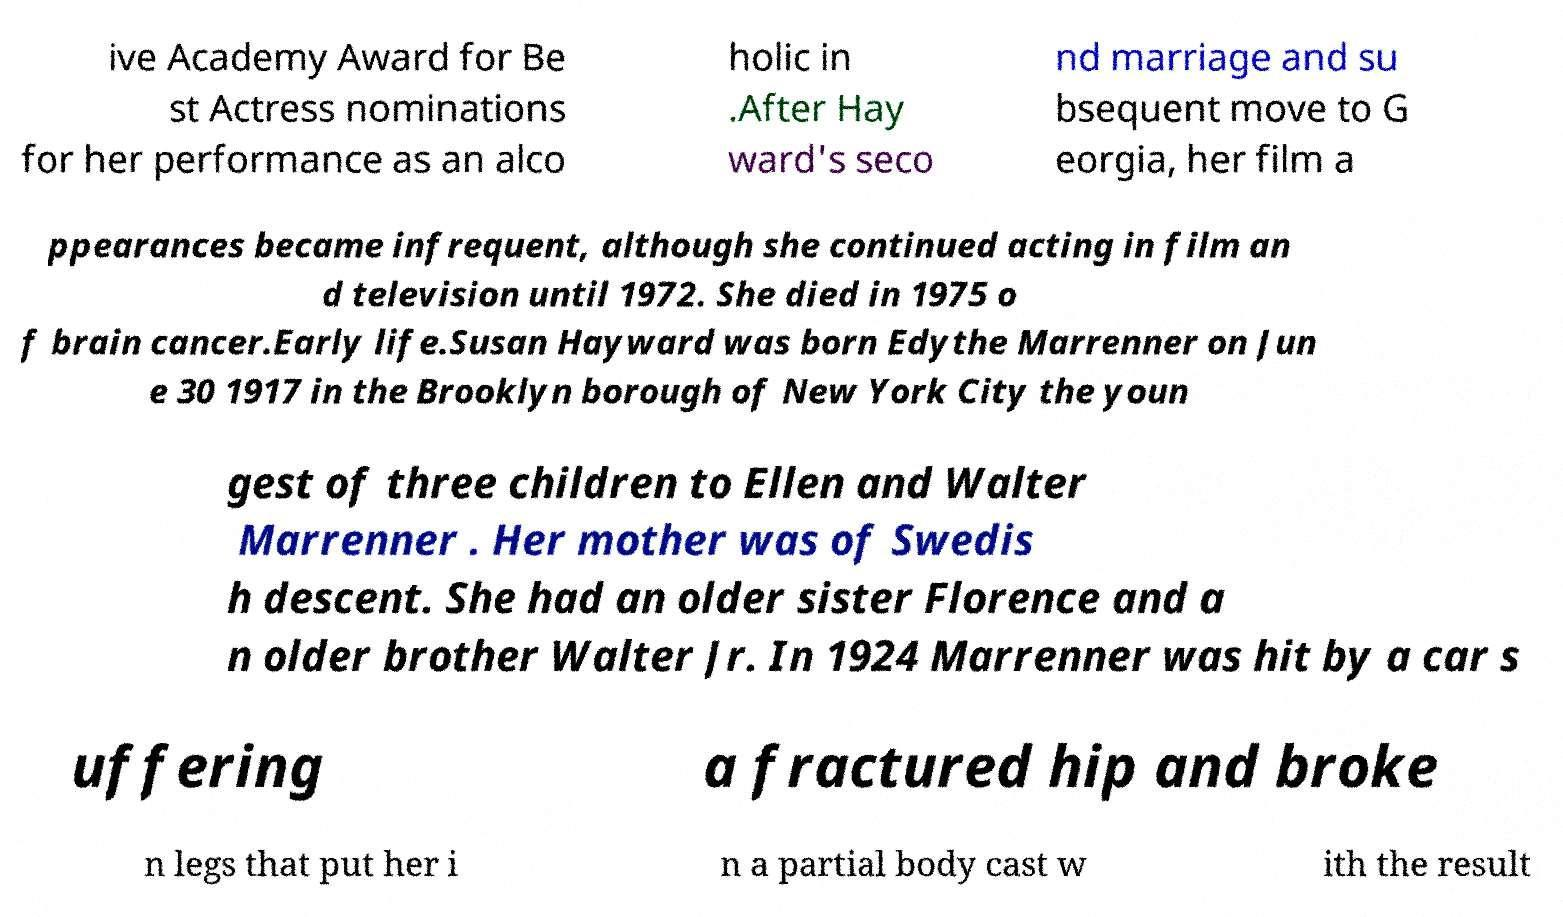Could you assist in decoding the text presented in this image and type it out clearly? ive Academy Award for Be st Actress nominations for her performance as an alco holic in .After Hay ward's seco nd marriage and su bsequent move to G eorgia, her film a ppearances became infrequent, although she continued acting in film an d television until 1972. She died in 1975 o f brain cancer.Early life.Susan Hayward was born Edythe Marrenner on Jun e 30 1917 in the Brooklyn borough of New York City the youn gest of three children to Ellen and Walter Marrenner . Her mother was of Swedis h descent. She had an older sister Florence and a n older brother Walter Jr. In 1924 Marrenner was hit by a car s uffering a fractured hip and broke n legs that put her i n a partial body cast w ith the result 